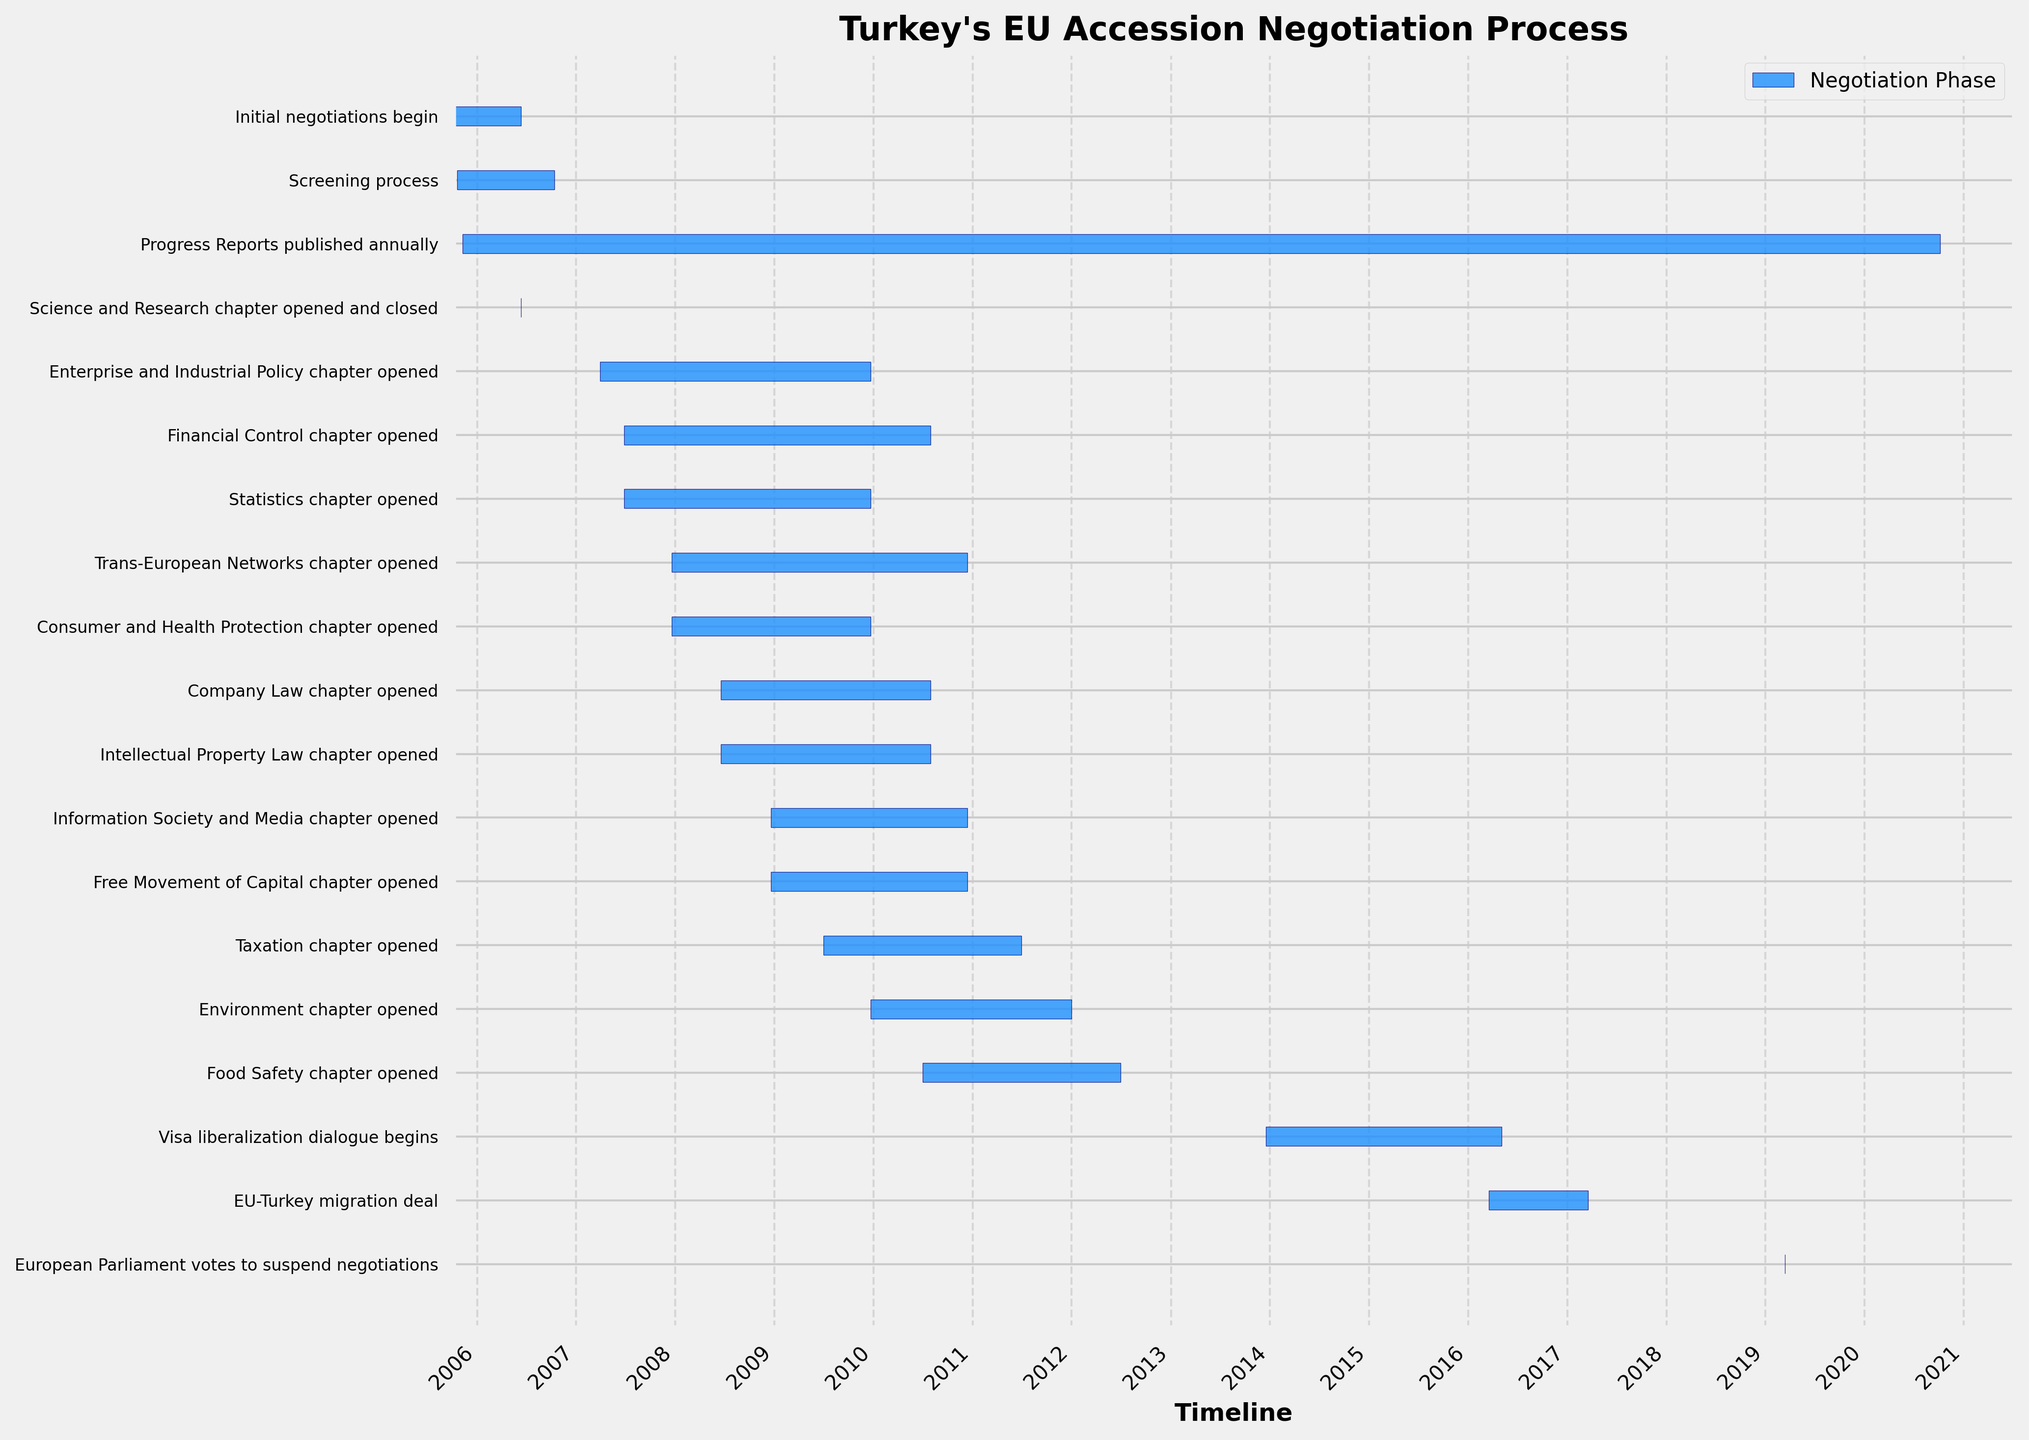What is the title of the figure? The title can be seen at the top of the Gantt Chart. Simply read it from there.
Answer: Turkey's EU Accession Negotiation Process Which task ended in March 2019? Locate the X-axis representing the timeline and find March 2019. From here, look upwards to find the corresponding task label on the Y-axis.
Answer: European Parliament votes to suspend negotiations How long did the Screening Process last? Identify the start and end dates of the Screening Process bar on the chart. Calculate the difference in days between the two dates.
Answer: 358 days Which task took more time, the Taxation chapter opened or the Food Safety chapter opened? Identify the length of the bars corresponding to each task. Compare the lengths to determine which one is longer.
Answer: Food Safety chapter opened How many tasks were initiated in 2007? Look at the X-axis ranges for 2007 and identify the tasks starting within this period. Count them.
Answer: 5 tasks Which tasks have the shortest duration? Identify the bars with the shortest length on the chart. Check the task labels corresponding to these bars.
Answer: Science and Research chapter opened, European Parliament votes to suspend negotiations Did any tasks start on the same day? Look for bars that have the same starting point along the X-axis. Cross-check their starting dates.
Answer: Yes, Financial Control chapter opened and Statistics chapter opened both started on 2007-06-26 Which task spans the longest duration? Compare the lengths of all bars on the chart. The longest bar corresponds to the task with the longest duration.
Answer: Progress Reports published annually How many tasks started after 2015? Look for bars starting after 2015 on the X-axis. Count each of these tasks.
Answer: 3 tasks Which tasks were ongoing in December 2008? Identify the timeline month on the X-axis. Look for bars that cover December 2008 within their duration and check the corresponding task labels.
Answer: Statistics chapter opened, Consumer and Health Protection chapter opened, Enterprise and Industrial Policy chapter opened, Trans-European Networks chapter opened, Financial Control chapter opened 